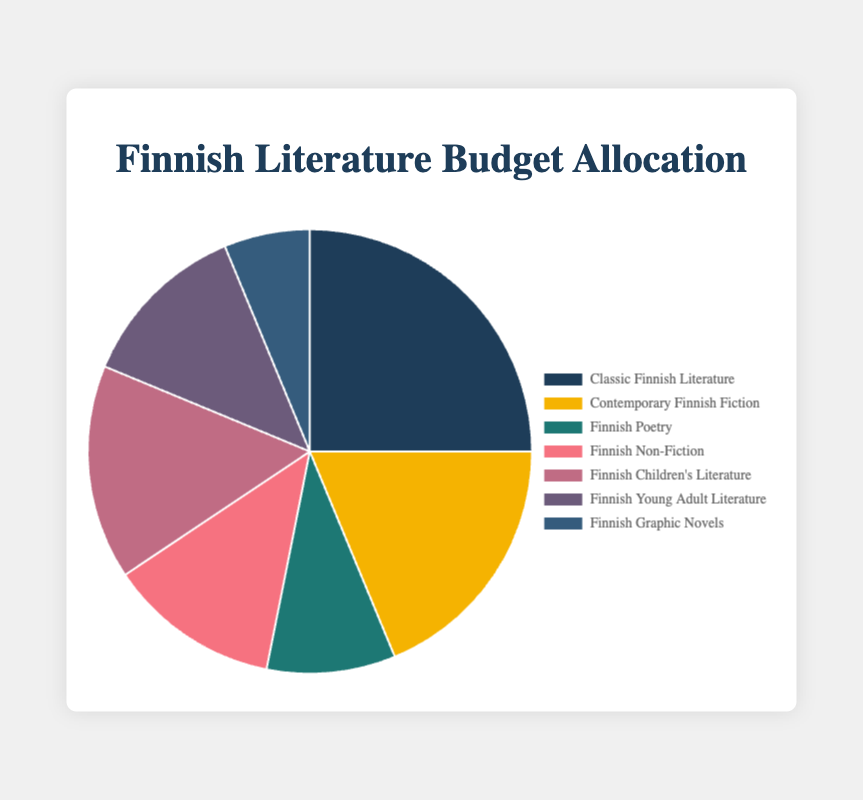Which category has the highest budget allocation? The category with the highest percentage in the pie chart has the highest budget allocation. In this case, "Classic Finnish Literature" has the highest percentage at 25%.
Answer: Classic Finnish Literature What is the combined budget allocation percentage for "Finnish Young Adult Literature" and "Finnish Non-Fiction"? Add the percentages of "Finnish Young Adult Literature" (12.5%) and "Finnish Non-Fiction" (12.5%) to find the combined value. 12.5% + 12.5% = 25%.
Answer: 25% How much more is allocated to "Classic Finnish Literature" compared to "Finnish Graphic Novels"? Subtract the amount allocated to "Finnish Graphic Novels" (1000) from the amount allocated to "Classic Finnish Literature" (4000). 4000 - 1000 = 3000.
Answer: 3000 Which two categories combined have the smallest total budget allocation, and what is their combined amount? The categories with the smallest percentages are "Finnish Graphic Novels" (6.25%) and "Finnish Poetry" (9.375%). Their corresponding amounts are 1000 and 1500 respectively. Adding these gives: 1000 + 1500 = 2500.
Answer: Finnish Graphic Novels and Finnish Poetry, 2500 What is the ratio of the budget allocation between "Contemporary Finnish Fiction" and "Finnish Children’s Literature"? Divide the budget allocation of "Contemporary Finnish Fiction" (3000) by the budget allocation of "Finnish Children’s Literature" (2500). 3000/2500 = 1.2.
Answer: 1.2 Which category has the smallest budget allocation and what is its percentage? The segment with the smallest percentage in the pie chart is "Finnish Graphic Novels" at 6.25%.
Answer: Finnish Graphic Novels, 6.25% What is the average budget allocation percentage for all the categories? Add up all the percentages and divide by the number of categories. (25 + 18.75 + 9.375 + 12.5 + 15.625 + 12.5 + 6.25) / 7 = 100 / 7 = 14.29%.
Answer: 14.29% How does the allocation for "Finnish Children’s Literature" compare visually to "Finnish Young Adult Literature"? Both categories have visually similar sections, indicating they both have a similar percentage of budget allocation. Their allocations are 15.625% and 12.5% respectively, which are close.
Answer: Similar If the entire budget is $16,000, what portion is allocated to "Finnish Poetry"? Use the percentage allocation of "Finnish Poetry" (9.375%) to calculate its portion of the total budget. 16000 * (9.375/100) = 1500.
Answer: 1500 What is the difference in allocation between "Contemporary Finnish Fiction" and "Finnish Children’s Literature"? Subtract the amount allocated to "Finnish Children’s Literature" (2500) from that of "Contemporary Finnish Fiction" (3000). 3000 - 2500 = 500.
Answer: 500 